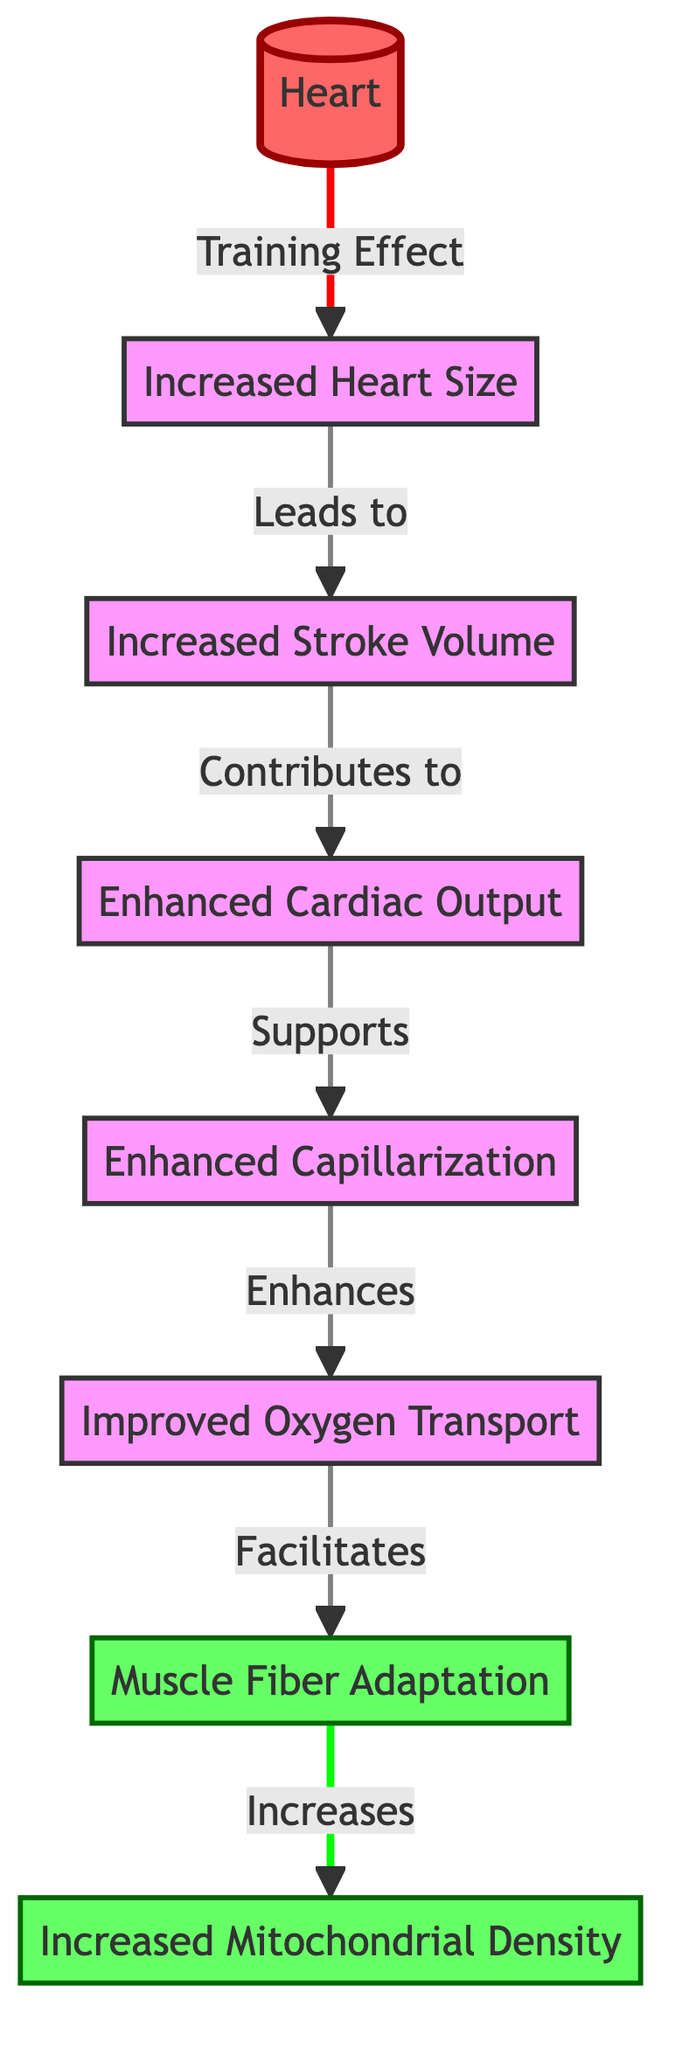What effect does training have on the heart? According to the diagram, the training effect leads to an "Increased Heart Size." This relationship is shown by the arrow connecting "Heart" to "Increased Heart Size."
Answer: Increased Heart Size What contributes to enhanced cardiac output? The diagram indicates that "Stroke Volume" contributes to "Enhanced Cardiac Output," as shown by the arrow between these two nodes.
Answer: Stroke Volume How many adaptations are presented in the diagram? The diagram lists a total of three adaptations: "Muscle Fiber Adaptation," "Increased Mitochondrial Density," and the enhancements leading to "Oxygen Transport." Therefore, the count includes multiple adaptations. This can be confirmed by counting the adaptation labels and their paths.
Answer: Three What is the relationship between oxygen transport and muscle fiber adaptation? The diagram highlights that "Improved Oxygen Transport" facilitates "Muscle Fiber Adaptation." This is indicated with an arrow directing from "Oxygen Transport" to "Muscle Fiber Adaptation."
Answer: Facilitates What is a direct outcome of increased heart size? The diagram states that "Increased Heart Size" leads to "Increased Stroke Volume," which is shown by a directed arrow from "Increased Heart Size" to "Stroke Volume."
Answer: Increased Stroke Volume How does enhanced cardiac output support capillarization? The diagram shows an arrow from "Enhanced Cardiac Output" to "Enhanced Capillarization," indicating that enhanced cardiac output directly supports capillarization. The underlying reasoning is that an increased cardiac output likely improves blood flow, thereby enhancing capillary growth.
Answer: Supports What does capillarization enhance? According to the diagram, "Enhanced Capillarization" enhances "Improved Oxygen Transport." This relationship is demonstrated by the arrow from "Capillarization" to "Oxygen Transport."
Answer: Improved Oxygen Transport Which adaptation is linked to increased mitochondrial density? The diagram shows that "Muscle Fiber Adaptation" increases "Increased Mitochondrial Density." The relationship is illustrated by the arrow leading from "Muscle Fiber Adaptation" to "Increased Mitochondrial Density."
Answer: Increased Mitochondrial Density 